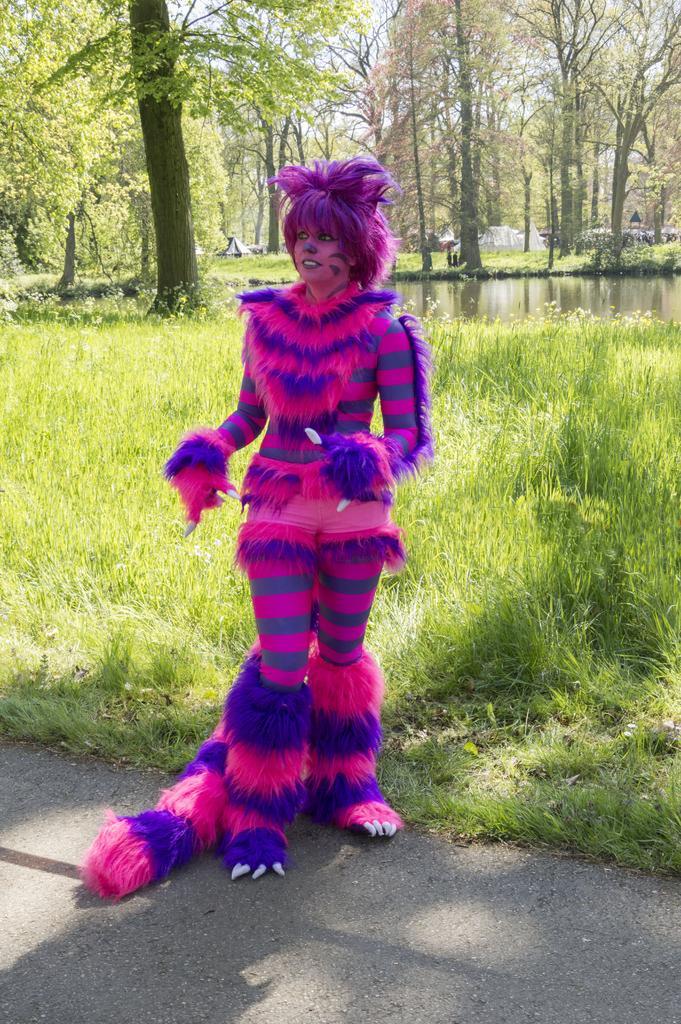In one or two sentences, can you explain what this image depicts? In the middle I can see a woman is standing on the road in a costume. In the background I can see grass, water, trees, hut and the sky. This image is taken during a sunny day. 